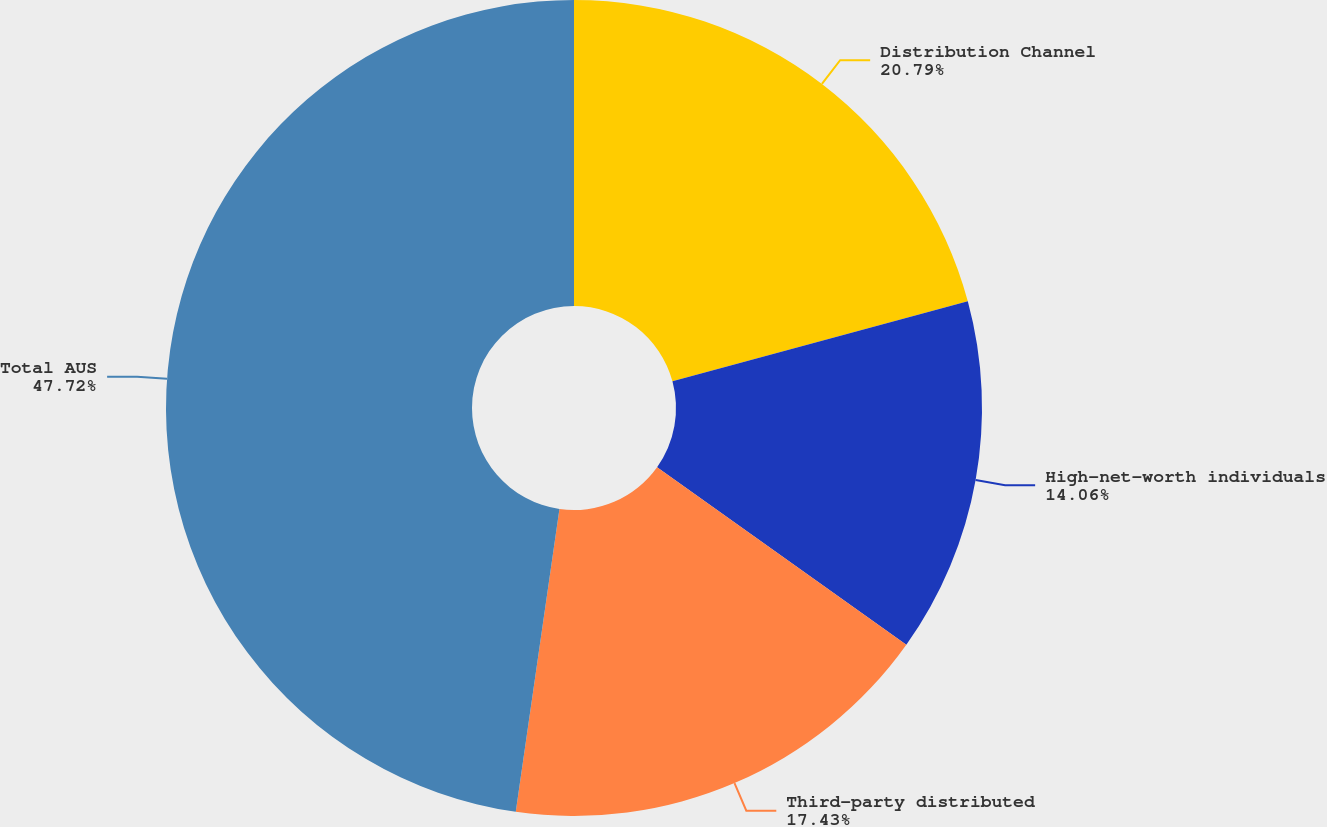<chart> <loc_0><loc_0><loc_500><loc_500><pie_chart><fcel>Distribution Channel<fcel>High-net-worth individuals<fcel>Third-party distributed<fcel>Total AUS<nl><fcel>20.79%<fcel>14.06%<fcel>17.43%<fcel>47.72%<nl></chart> 